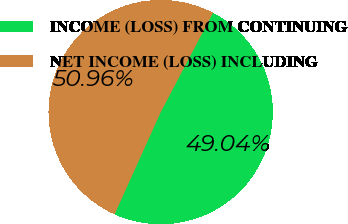<chart> <loc_0><loc_0><loc_500><loc_500><pie_chart><fcel>INCOME (LOSS) FROM CONTINUING<fcel>NET INCOME (LOSS) INCLUDING<nl><fcel>49.04%<fcel>50.96%<nl></chart> 